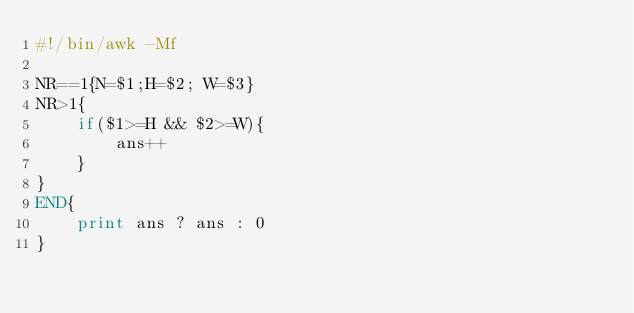<code> <loc_0><loc_0><loc_500><loc_500><_Awk_>#!/bin/awk -Mf

NR==1{N=$1;H=$2; W=$3}
NR>1{
    if($1>=H && $2>=W){
        ans++
    }
}
END{
    print ans ? ans : 0
}
</code> 